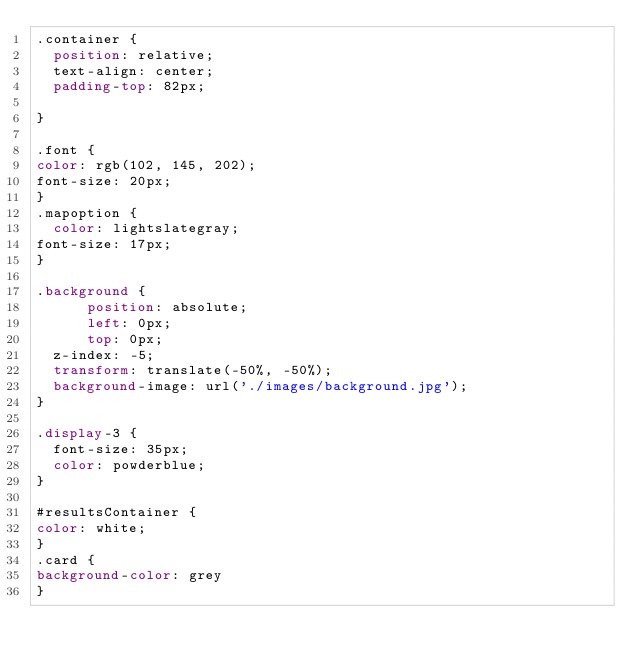Convert code to text. <code><loc_0><loc_0><loc_500><loc_500><_CSS_>.container {
  position: relative;
  text-align: center;
  padding-top: 82px;
  
}

.font {
color: rgb(102, 145, 202);
font-size: 20px;
}
.mapoption {
  color: lightslategray;
font-size: 17px;
}

.background {
      position: absolute;
      left: 0px;
      top: 0px;
  z-index: -5;
  transform: translate(-50%, -50%);
  background-image: url('./images/background.jpg');
}

.display-3 {
  font-size: 35px; 
  color: powderblue; 
}

#resultsContainer {
color: white;
}
.card {
background-color: grey  
}
</code> 